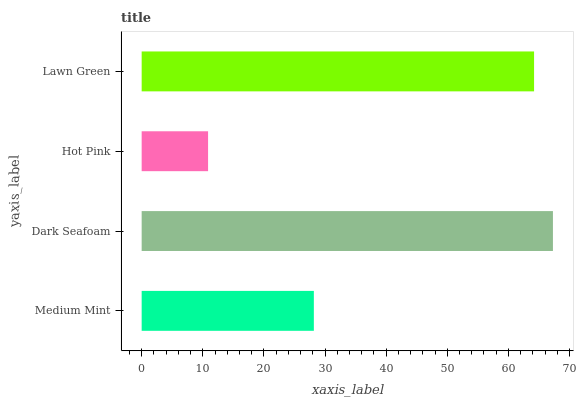Is Hot Pink the minimum?
Answer yes or no. Yes. Is Dark Seafoam the maximum?
Answer yes or no. Yes. Is Dark Seafoam the minimum?
Answer yes or no. No. Is Hot Pink the maximum?
Answer yes or no. No. Is Dark Seafoam greater than Hot Pink?
Answer yes or no. Yes. Is Hot Pink less than Dark Seafoam?
Answer yes or no. Yes. Is Hot Pink greater than Dark Seafoam?
Answer yes or no. No. Is Dark Seafoam less than Hot Pink?
Answer yes or no. No. Is Lawn Green the high median?
Answer yes or no. Yes. Is Medium Mint the low median?
Answer yes or no. Yes. Is Dark Seafoam the high median?
Answer yes or no. No. Is Hot Pink the low median?
Answer yes or no. No. 